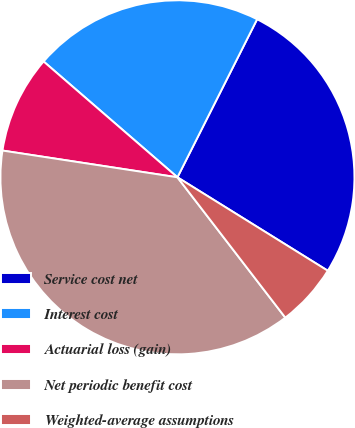<chart> <loc_0><loc_0><loc_500><loc_500><pie_chart><fcel>Service cost net<fcel>Interest cost<fcel>Actuarial loss (gain)<fcel>Net periodic benefit cost<fcel>Weighted-average assumptions<nl><fcel>26.42%<fcel>21.08%<fcel>8.94%<fcel>37.85%<fcel>5.72%<nl></chart> 